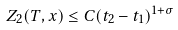Convert formula to latex. <formula><loc_0><loc_0><loc_500><loc_500>Z _ { 2 } ( T , x ) \leq C ( t _ { 2 } - t _ { 1 } ) ^ { 1 + \sigma }</formula> 